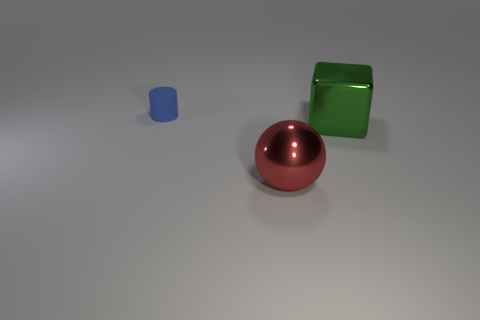Add 2 small gray things. How many objects exist? 5 Subtract all blocks. How many objects are left? 2 Subtract all cubes. Subtract all big shiny objects. How many objects are left? 0 Add 3 small blue cylinders. How many small blue cylinders are left? 4 Add 3 small brown metallic cubes. How many small brown metallic cubes exist? 3 Subtract 0 purple cylinders. How many objects are left? 3 